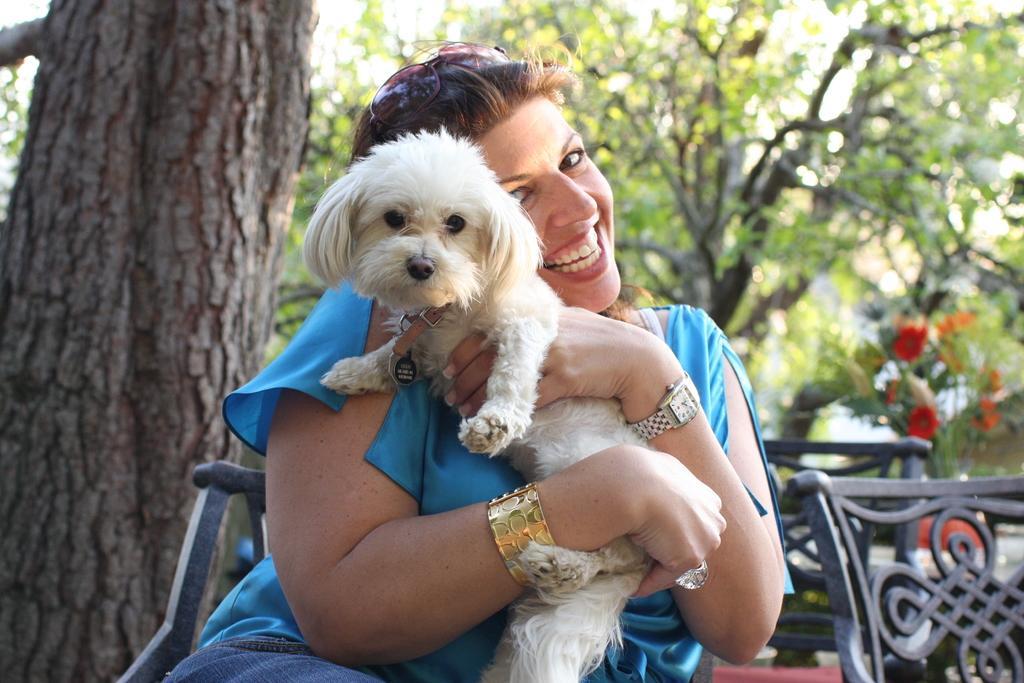In one or two sentences, can you explain what this image depicts? In the center of the image, we can see a lady sitting on the chair and holding a puppy. In the background, there are chairs, trees and we can see a flower pot. 